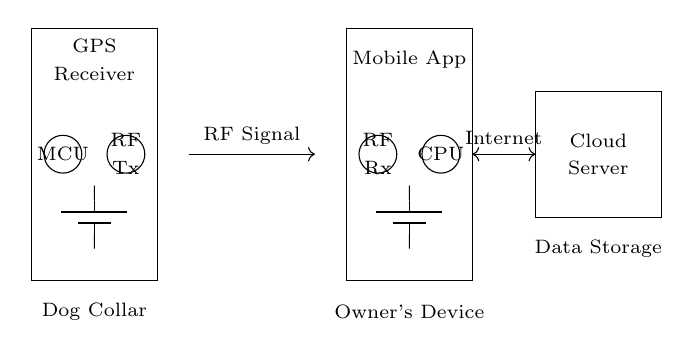What is the operating voltage of the dog collar circuit? The voltage is indicated by the battery symbol, which generally represents a battery supplying 5 volts for the operation of the collar system.
Answer: 5 volts What components are used in the dog's collar? The components in the collar include a GPS receiver, an MCU (microcontroller unit), and an RF transmitter, which are indicated within the rectangle labeled "Dog Collar."
Answer: GPS receiver, MCU, RF transmitter What is the role of the RF transmitter? The RF transmitter sends radio frequency signals to communicate the dog's location data to the owner's device. This function is implied by its labeling and connection to the wireless transmission line.
Answer: Communication How does the dog's collar connect to the owner's device? The collar connects to the owner's device via wireless transmission labeled as "RF Signal," which shows a directional arrow indicating the flow of information.
Answer: RF signal What connects the owner's device to the cloud server? An internet connection is shown as a bidirectional arrow connecting the owner's device and the cloud server, indicating data transfer between these components.
Answer: Internet Which device receives RF signals in the owner's device? The device that receives RF signals is labeled as "RF Rx" (RF Receiver), indicating its function in receiving the data transmitted from the collar.
Answer: RF Receiver What is the purpose of the cloud server in this circuit? The cloud server is intended for data storage and is indicated by the label "Cloud Server," showing its role in storing and processing the data collected from the collar.
Answer: Data storage 